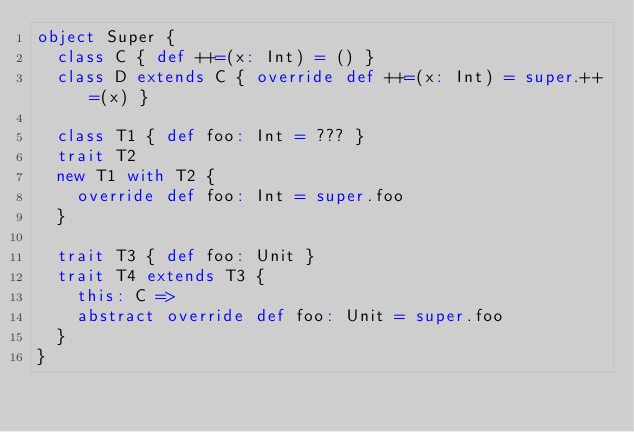Convert code to text. <code><loc_0><loc_0><loc_500><loc_500><_Scala_>object Super {
  class C { def ++=(x: Int) = () }
  class D extends C { override def ++=(x: Int) = super.++=(x) }

  class T1 { def foo: Int = ??? }
  trait T2
  new T1 with T2 {
    override def foo: Int = super.foo
  }

  trait T3 { def foo: Unit }
  trait T4 extends T3 {
    this: C =>
    abstract override def foo: Unit = super.foo
  }
}</code> 